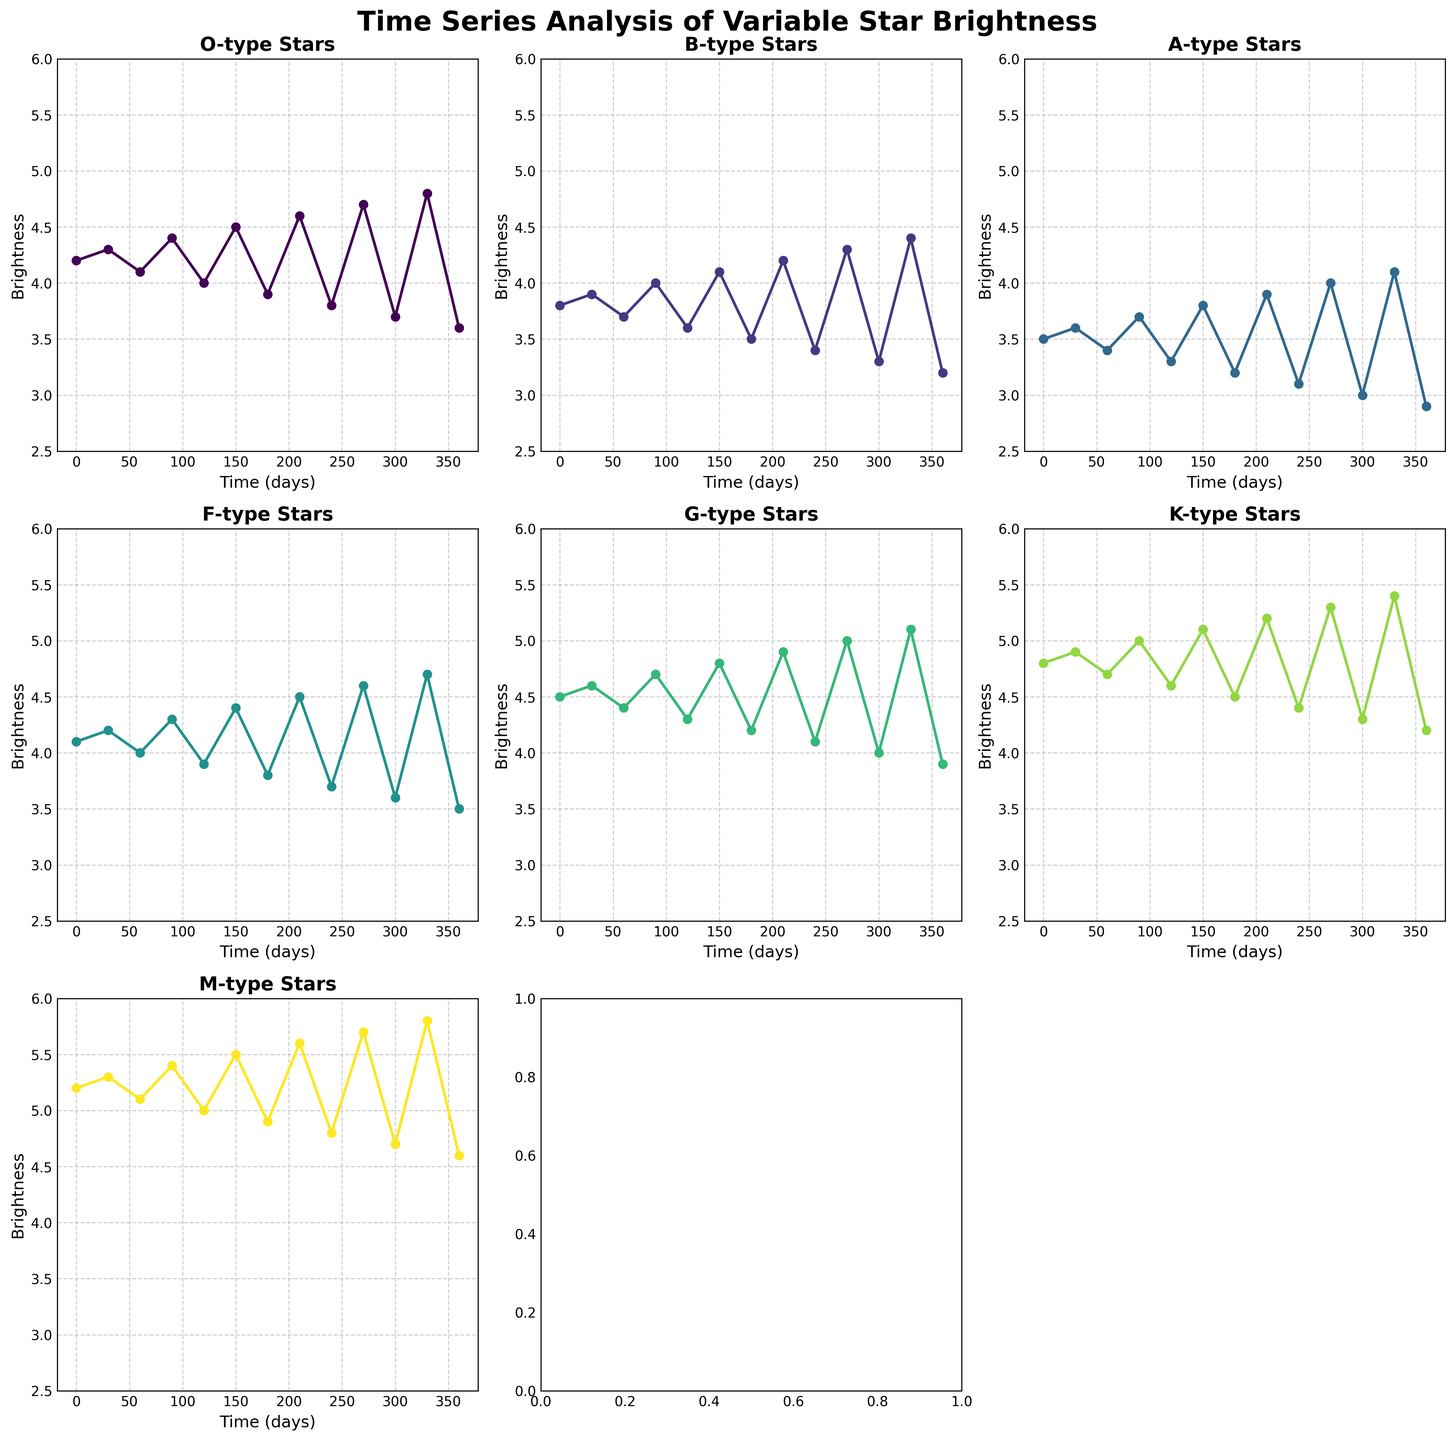What is the title of the figure? The title is displayed at the top of the figure in bold font, indicating the main subject of the figure.
Answer: Time Series Analysis of Variable Star Brightness How many star types are represented in the figure? The figure contains subplots for each star type, and by counting the subplots, we can determine the number of star types. There are 7 star types mentioned in the figure.
Answer: 7 Which star type has the highest maximum brightness value? By examining the plots for all star types, find the one with the highest point on the y-axis. The O-type star subplot shows a maximum brightness of 4.8.
Answer: O-type What is the general trend of the brightness for M-type stars over the time period? By following the curve in the M-type subplot, we notice the brightness generally fluctuates but shows a slight increase over time.
Answer: Slight increase At the midpoint time (180 days), which star type has the lowest brightness? Locate the 180-day mark on each subplot and compare the brightness values. The K-type star shows the lowest brightness at this point with a value of 4.5.
Answer: K-type Compare the brightness of O-type and G-type stars at the 150-day mark. Which is higher? Locate the 150-day mark on both O-type and G-type subplots and compare the respective brightness values. O-type has a brightness of 4.5, and G-type has 4.8, so G-type is higher.
Answer: G-type What can be inferred about the brightness variability among the different star types? By comparing the range of brightness values in each subplot, we observe that different star types have varying degrees of brightness variability. Generally, the higher the stellar classification, the greater the fluctuation in brightness.
Answer: Higher variability in higher classifications What is the average brightness of B-type stars over the given time period? Sum all the brightness values for B-type stars and divide by the number of data points (13). Calculation: (3.8 + 3.9 + 3.7 + 4.0 + 3.6 + 4.1 + 3.5 + 4.2 + 3.4 + 4.3 + 3.3 + 4.4 + 3.2)/13 = 3.84
Answer: 3.84 Which star type shows the most consistent brightness pattern over time? By assessing the fluctuation range in each subplot, the A-type stars show the least amount of variation in brightness, indicating a more consistent brightness pattern.
Answer: A-type How does the brightness of K-type stars at 90 days compare to their brightness at 360 days? Check both the 90-day and 360-day marks on the K-type subplot. At 90 days, the brightness is 5.0, and at 360 days it is 4.2. Hence, the brightness decreases from 90 to 360 days.
Answer: Decreases 